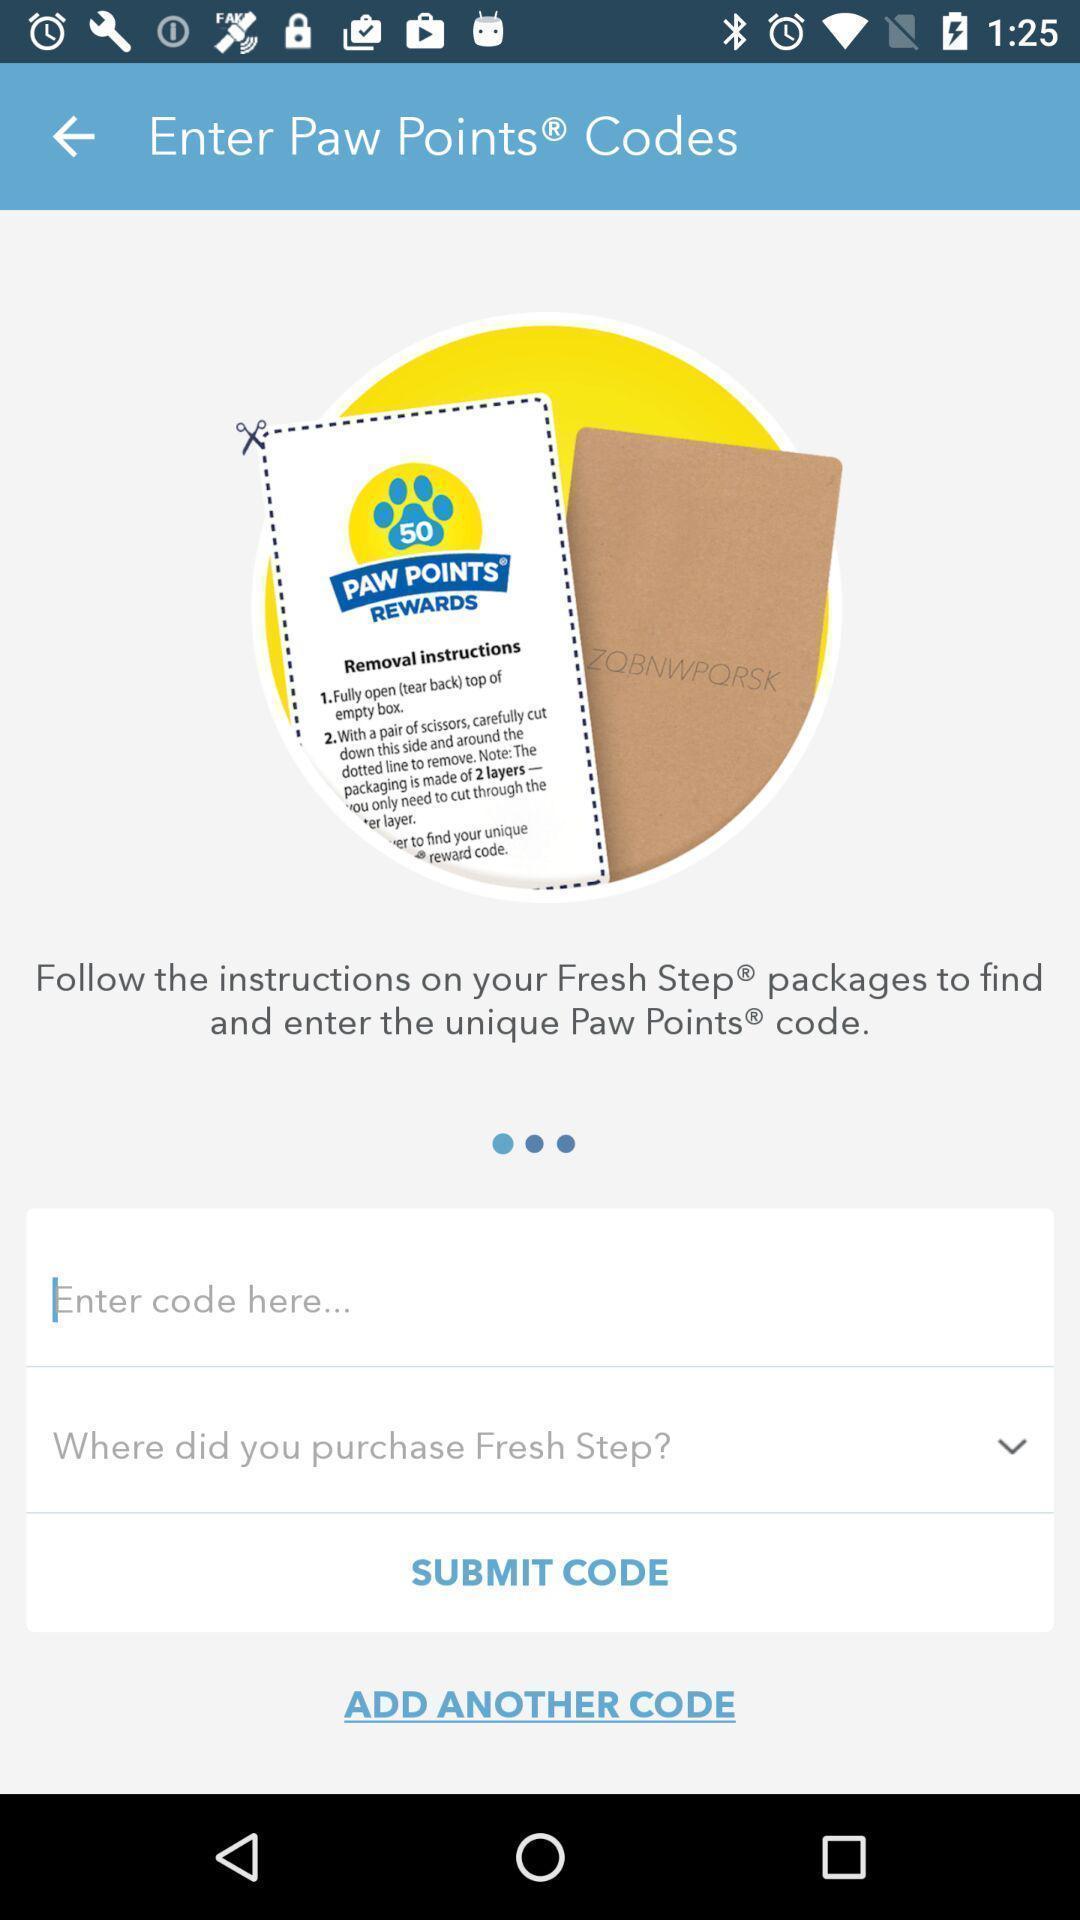Describe this image in words. Page with information and to enter code with submit option. 